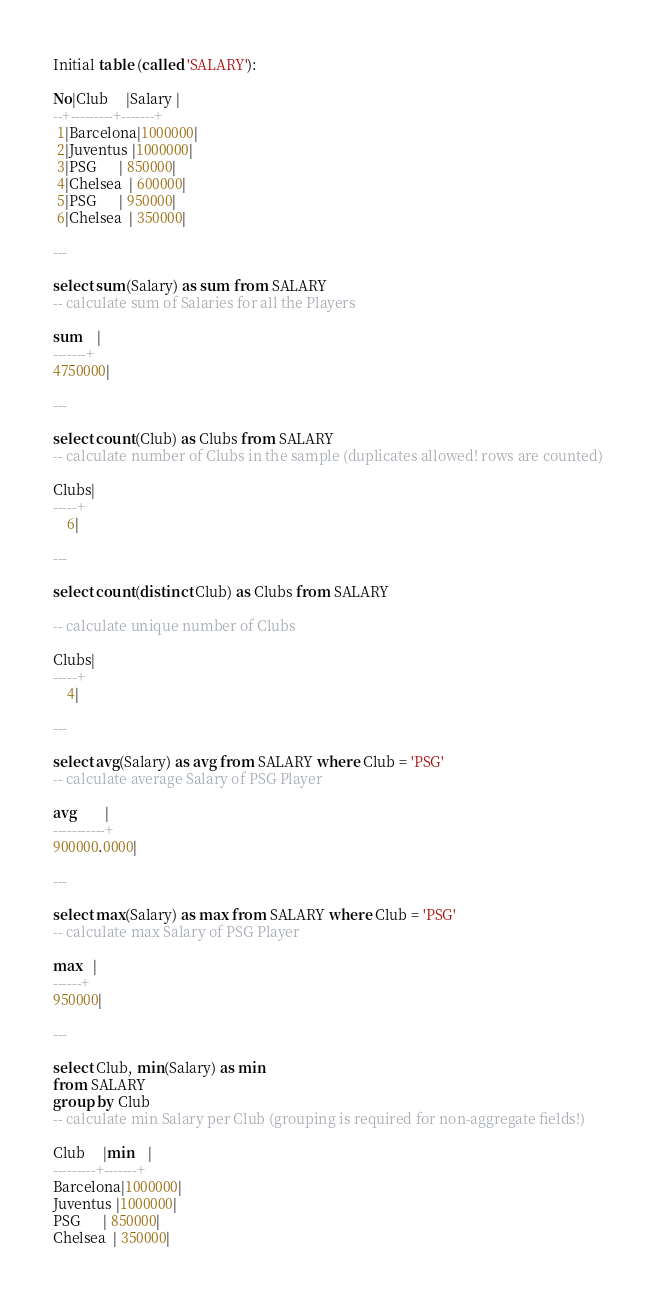<code> <loc_0><loc_0><loc_500><loc_500><_SQL_>Initial table (called 'SALARY'):

No|Club     |Salary |
--+---------+-------+
 1|Barcelona|1000000|
 2|Juventus |1000000|
 3|PSG      | 850000|
 4|Chelsea  | 600000|
 5|PSG      | 950000|
 6|Chelsea  | 350000|

---

select sum(Salary) as sum from SALARY
-- calculate sum of Salaries for all the Players

sum    |
-------+
4750000|

---

select count(Club) as Clubs from SALARY
-- calculate number of Clubs in the sample (duplicates allowed! rows are counted)

Clubs|
-----+
    6|

---

select count(distinct Club) as Clubs from SALARY

-- calculate unique number of Clubs

Clubs|
-----+
    4|

---

select avg(Salary) as avg from SALARY where Club = 'PSG'
-- calculate average Salary of PSG Player

avg        |
-----------+
900000.0000|

---

select max(Salary) as max from SALARY where Club = 'PSG'
-- calculate max Salary of PSG Player

max   |
------+
950000|

---

select Club, min(Salary) as min
from SALARY
group by Club
-- calculate min Salary per Club (grouping is required for non-aggregate fields!)

Club     |min    |
---------+-------+
Barcelona|1000000|
Juventus |1000000|
PSG      | 850000|
Chelsea  | 350000|
</code> 